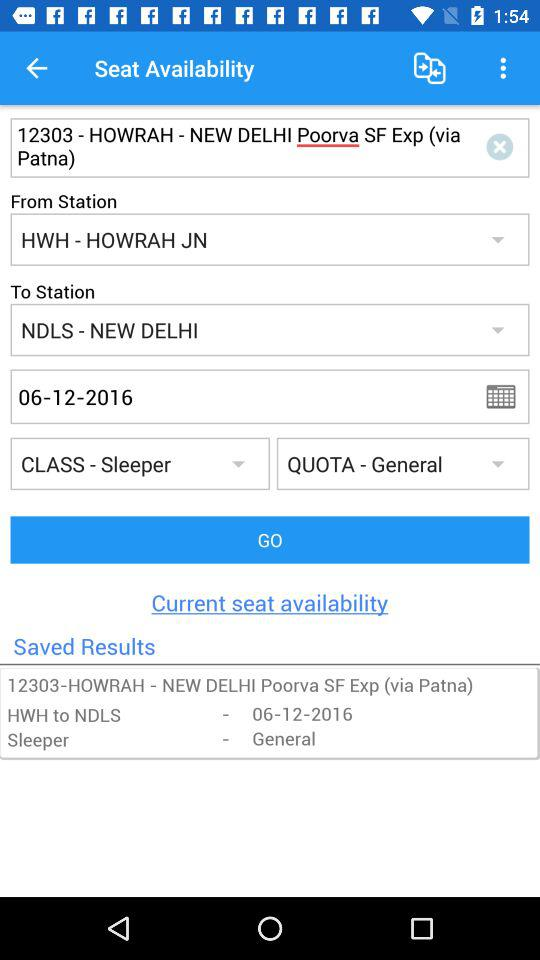What is the destination station? The destination station is NDLS - New Delhi. 